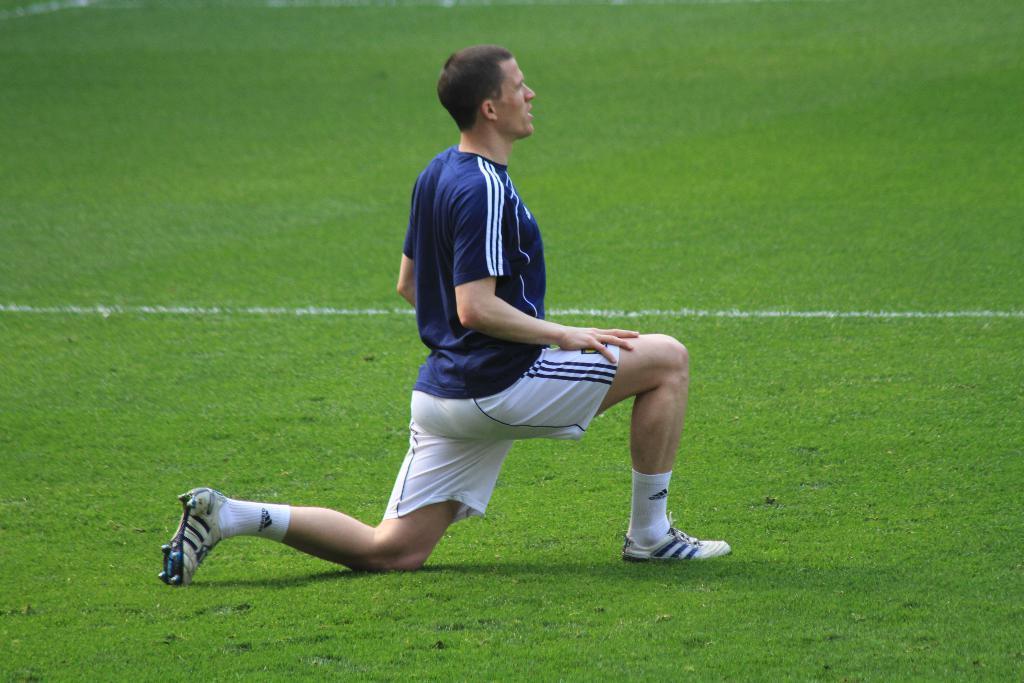Can you describe this image briefly? In this picture there is a person with blue t-shirt is on his knees. At the bottom there is grass. 